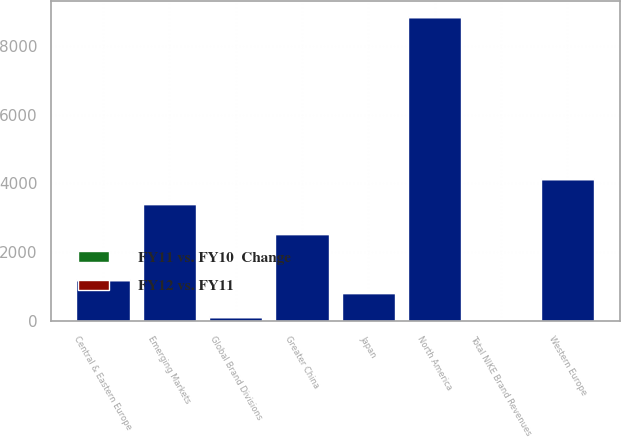Convert chart to OTSL. <chart><loc_0><loc_0><loc_500><loc_500><stacked_bar_chart><ecel><fcel>North America<fcel>Western Europe<fcel>Central & Eastern Europe<fcel>Greater China<fcel>Japan<fcel>Emerging Markets<fcel>Global Brand Divisions<fcel>Total NIKE Brand Revenues<nl><fcel>nan<fcel>8839<fcel>4144<fcel>1200<fcel>2539<fcel>829<fcel>3410<fcel>111<fcel>17<nl><fcel>FY12 vs. FY11<fcel>17<fcel>4<fcel>17<fcel>18<fcel>1<fcel>26<fcel>13<fcel>15<nl><fcel>FY11 vs. FY10  Change<fcel>13<fcel>1<fcel>4<fcel>18<fcel>13<fcel>24<fcel>12<fcel>10<nl></chart> 